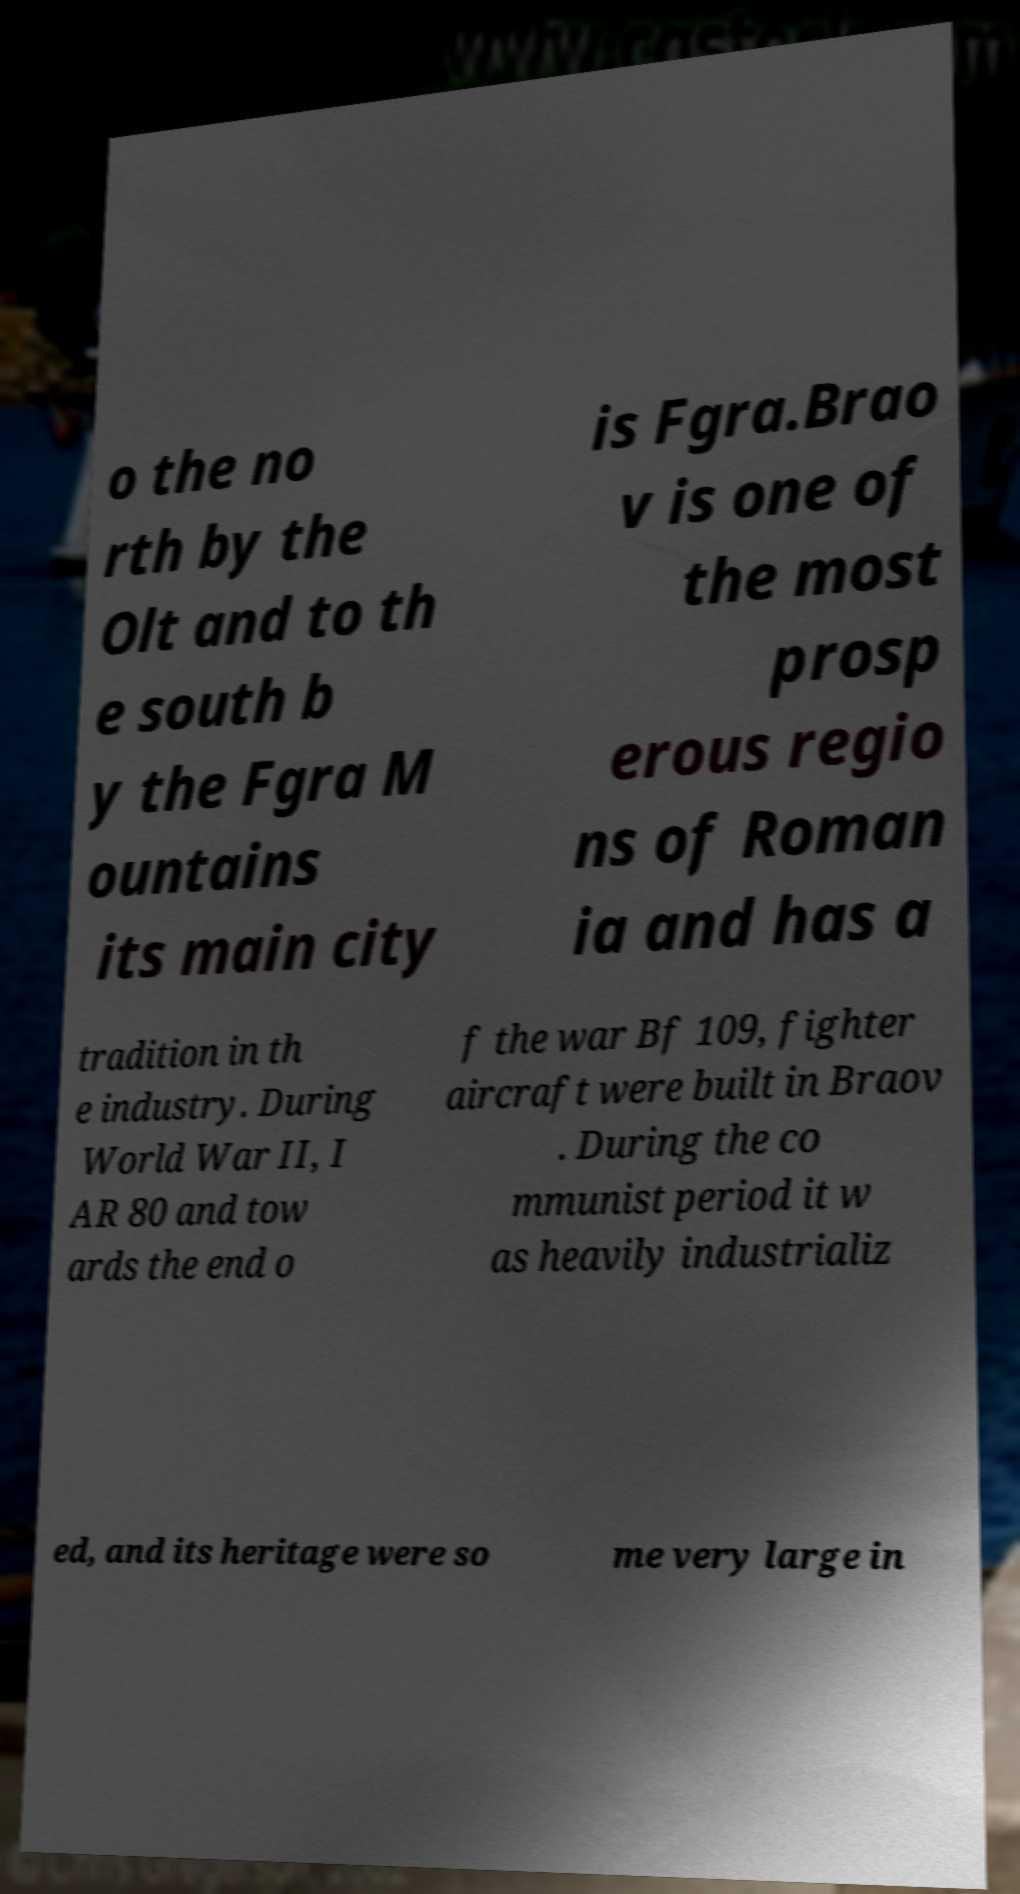I need the written content from this picture converted into text. Can you do that? o the no rth by the Olt and to th e south b y the Fgra M ountains its main city is Fgra.Brao v is one of the most prosp erous regio ns of Roman ia and has a tradition in th e industry. During World War II, I AR 80 and tow ards the end o f the war Bf 109, fighter aircraft were built in Braov . During the co mmunist period it w as heavily industrializ ed, and its heritage were so me very large in 